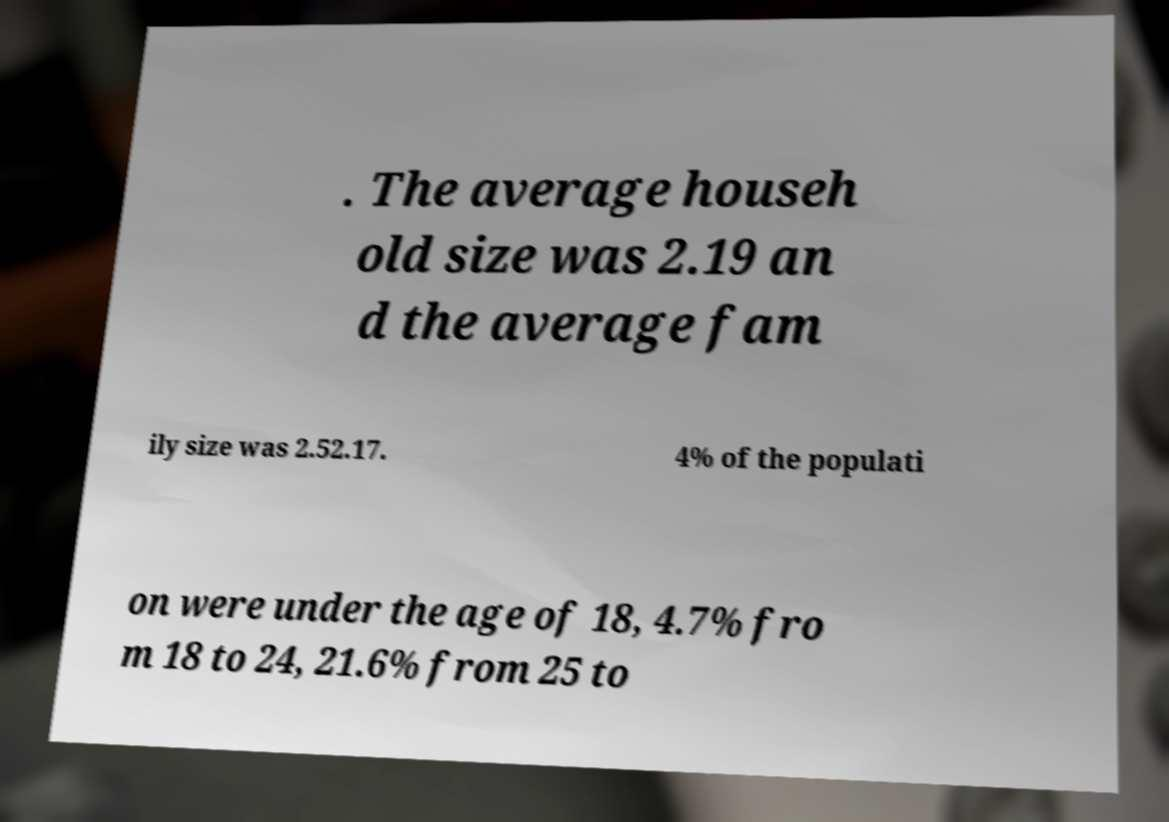Can you read and provide the text displayed in the image?This photo seems to have some interesting text. Can you extract and type it out for me? . The average househ old size was 2.19 an d the average fam ily size was 2.52.17. 4% of the populati on were under the age of 18, 4.7% fro m 18 to 24, 21.6% from 25 to 